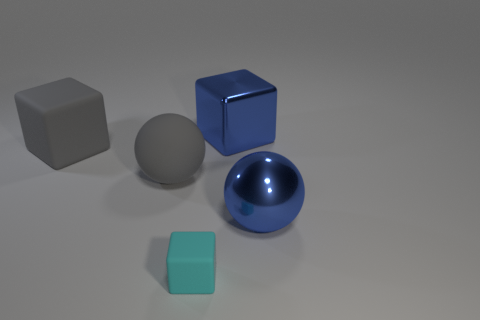The big thing that is behind the gray matte sphere and on the right side of the tiny matte block is what color?
Offer a very short reply. Blue. Do the cyan rubber thing and the blue metallic thing that is in front of the large blue cube have the same size?
Your answer should be compact. No. Is there any other thing that has the same shape as the small cyan thing?
Keep it short and to the point. Yes. What is the color of the other matte thing that is the same shape as the tiny cyan thing?
Offer a terse response. Gray. Is the cyan matte block the same size as the metal ball?
Offer a terse response. No. How many other things are the same size as the cyan rubber block?
Give a very brief answer. 0. How many things are big things that are to the left of the small cyan matte cube or small cyan objects in front of the large rubber block?
Your response must be concise. 3. What shape is the blue metal thing that is the same size as the blue cube?
Offer a terse response. Sphere. What size is the gray thing that is the same material as the gray ball?
Provide a short and direct response. Large. The rubber block that is the same size as the shiny ball is what color?
Keep it short and to the point. Gray. 